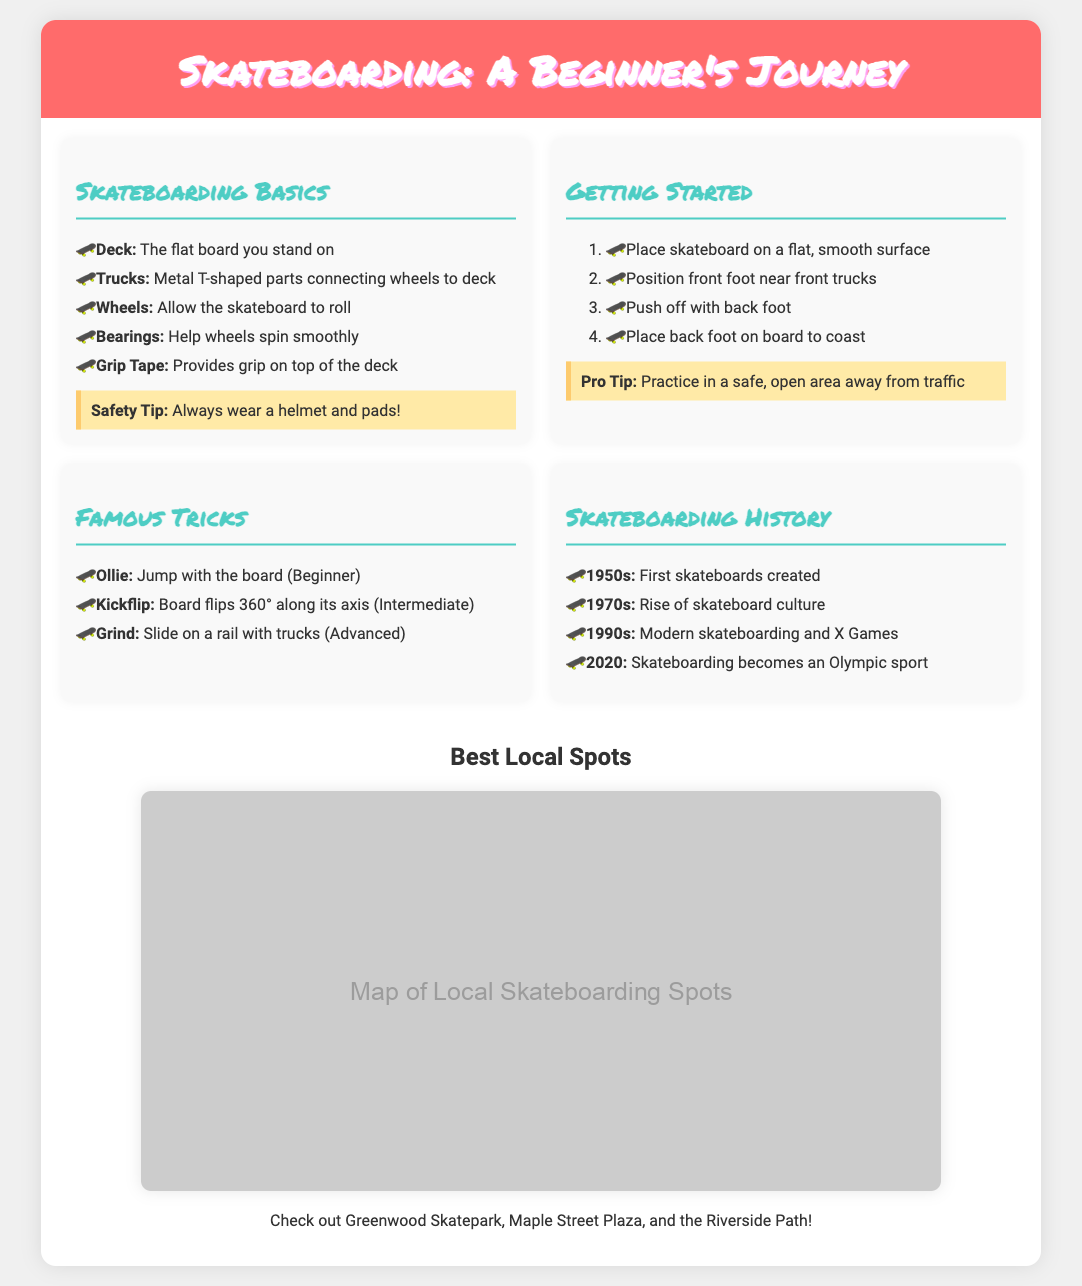What is the main title of the poster? The main title is prominently displayed at the top of the poster.
Answer: Skateboarding: A Beginner's Journey What is the first trick mentioned in the Famous Tricks section? The list of tricks includes a variety of famous skateboard tricks.
Answer: Ollie What safety gear is advised in the Skateboarding Basics section? The section emphasizes the importance of wearing protective equipment for safety.
Answer: Helmet and pads In which decade did skateboarding become an Olympic sport? The timeline in the history section indicates significant events, including this one.
Answer: 2020 What is the primary function of the wheels on a skateboard? The description in the Skateboarding Basics section provides insights into skateboard parts and their functions.
Answer: Allow the skateboard to roll Which skateboarding spot is highlighted in the Best Local Spots section? The map and accompanying text point out popular locations in the area for skating.
Answer: Greenwood Skatepark What are the four steps listed to get started with skateboarding? The Getting Started section provides a sequence of actions necessary for beginners.
Answer: Place skateboard, Position front foot, Push off, Place back foot What is the skill level required to perform a Kickflip? Each trick description includes an indication of the skill level needed for mastery.
Answer: Intermediate What is illustrated in the section titled Skateboarding History? This section presents a chronological account of skateboard development and historical milestones.
Answer: Timeline with key events 